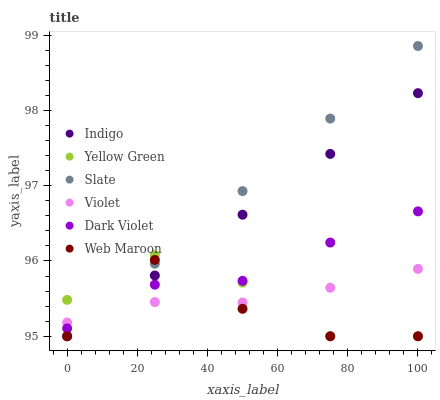Does Web Maroon have the minimum area under the curve?
Answer yes or no. Yes. Does Slate have the maximum area under the curve?
Answer yes or no. Yes. Does Yellow Green have the minimum area under the curve?
Answer yes or no. No. Does Yellow Green have the maximum area under the curve?
Answer yes or no. No. Is Indigo the smoothest?
Answer yes or no. Yes. Is Web Maroon the roughest?
Answer yes or no. Yes. Is Yellow Green the smoothest?
Answer yes or no. No. Is Yellow Green the roughest?
Answer yes or no. No. Does Indigo have the lowest value?
Answer yes or no. Yes. Does Dark Violet have the lowest value?
Answer yes or no. No. Does Slate have the highest value?
Answer yes or no. Yes. Does Yellow Green have the highest value?
Answer yes or no. No. Does Slate intersect Violet?
Answer yes or no. Yes. Is Slate less than Violet?
Answer yes or no. No. Is Slate greater than Violet?
Answer yes or no. No. 